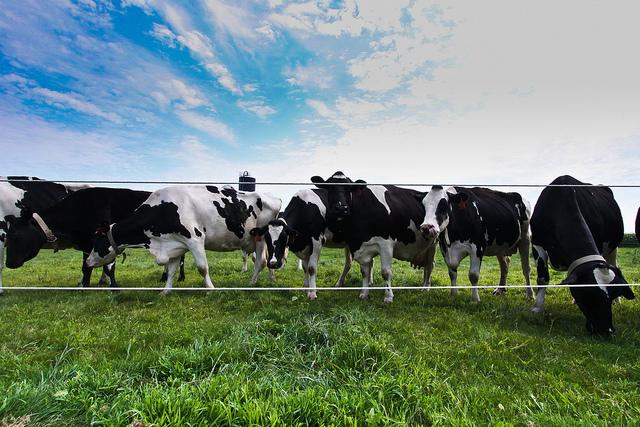Are these milk cows?
Short answer required. Yes. The animals are all black?
Short answer required. No. Would these animals be considered cattle?
Short answer required. Yes. What are these cow doing?
Answer briefly. Eating. 